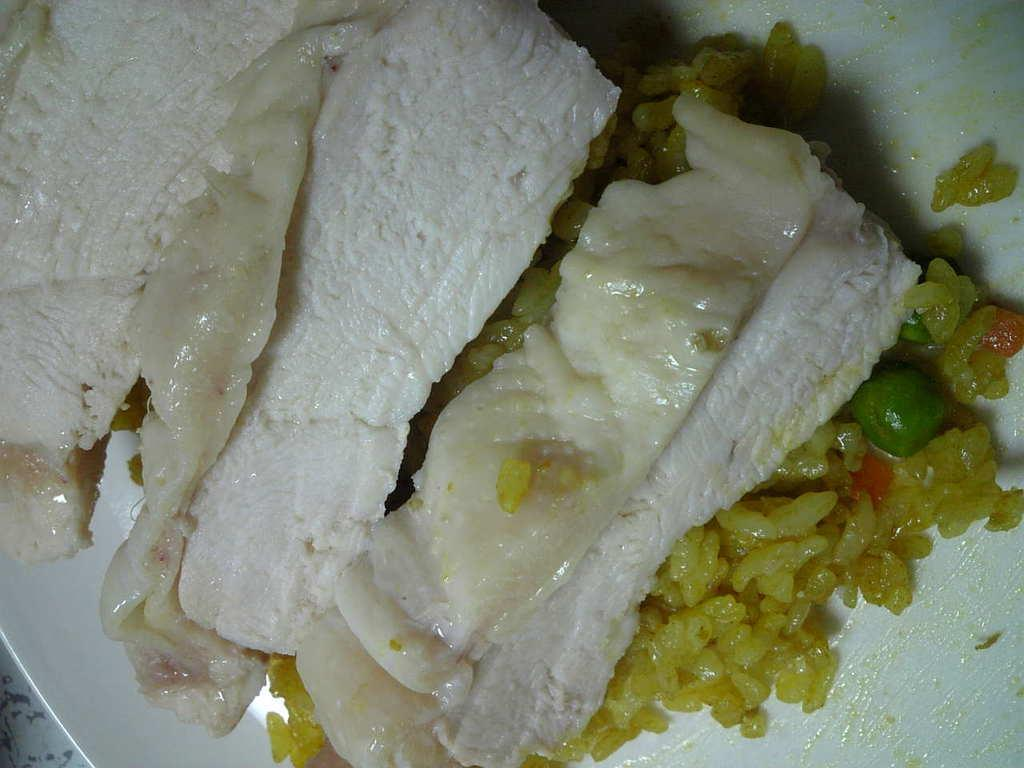What type of food is on the plate in the image? There is rice on a plate in the image. Are there any other food items on the plate? Yes, there are other food items on the plate. What color is the plate? The plate is white. What type of bell can be heard ringing in the image? There is no bell present in the image, and therefore no sound can be heard. 